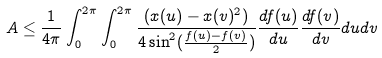<formula> <loc_0><loc_0><loc_500><loc_500>A \leq \frac { 1 } { 4 \pi } \int _ { 0 } ^ { 2 \pi } \int _ { 0 } ^ { 2 \pi } \frac { ( x ( u ) - x ( v ) ^ { 2 } ) } { 4 \sin ^ { 2 } ( \frac { f ( u ) - f ( v ) } { 2 } ) } \frac { d f ( u ) } { d u } \frac { d f ( v ) } { d v } d u d v</formula> 